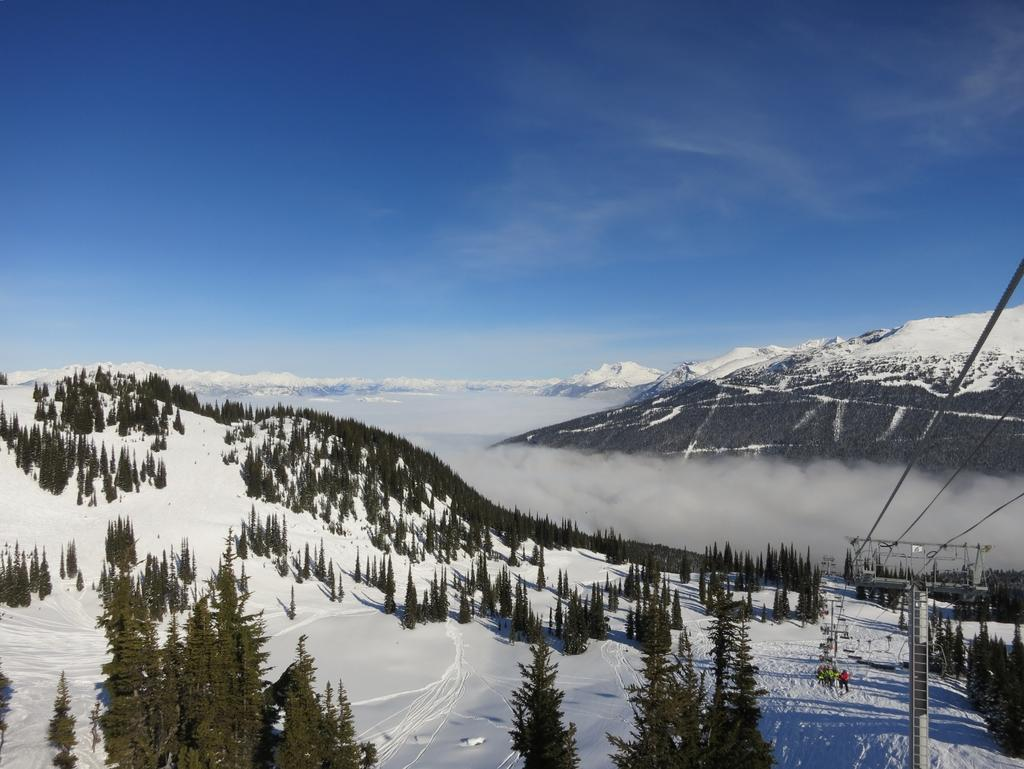What type of natural features can be seen in the image? There are trees and mountains in the image. Are there any human elements in the image? Yes, there are people in the image. What mode of transportation is visible in the image? There is a ropeway in the image. What is the ground condition at the bottom of the image? There is snow at the bottom of the image. What is visible at the top of the image? The sky is visible at the top of the image. What type of noise can be heard coming from the cow in the image? There is no cow present in the image, so it is not possible to determine what noise might be heard. 